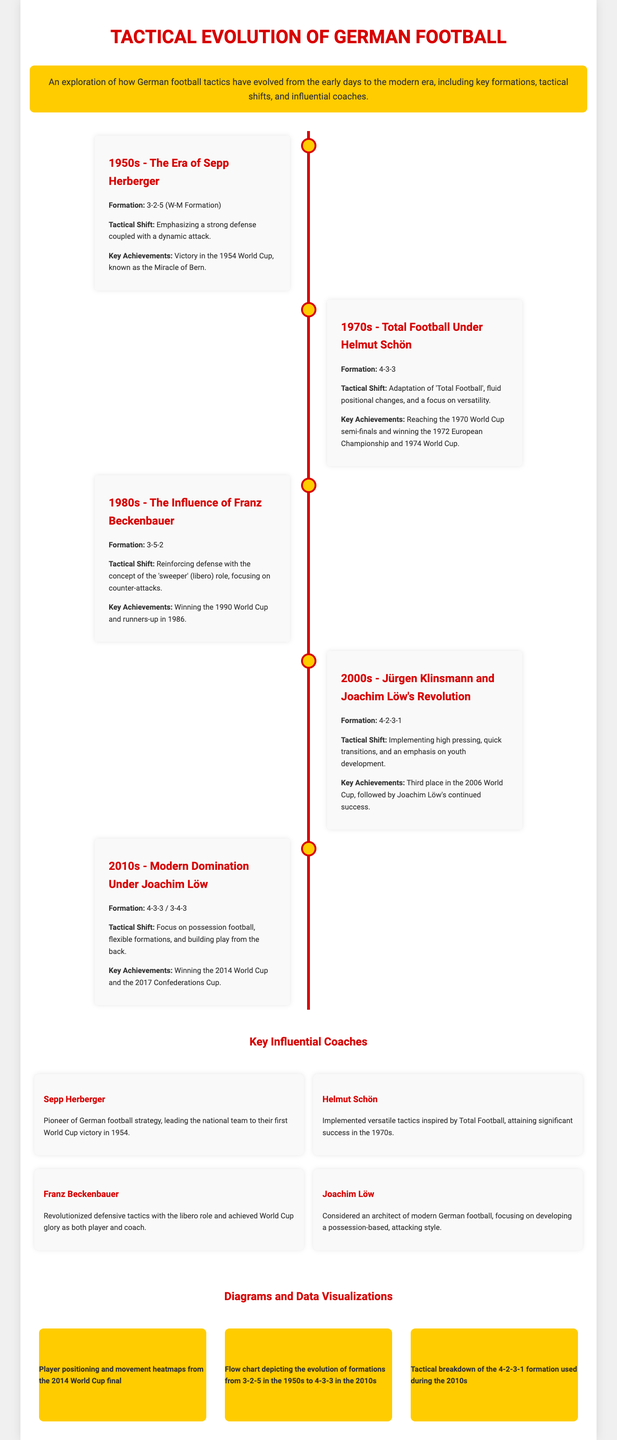What was the formation used in the 1950s? The 1950s era used the 3-2-5 formation, also known as the W-M Formation.
Answer: 3-2-5 Who was the coach during the 1970s? The coach during the 1970s was Helmut Schön.
Answer: Helmut Schön Which World Cup did Germany win in 1990? The document states Germany won the World Cup, specifically mentioning 1990 as a key achievement.
Answer: 1990 What was the key tactical shift under Joachim Löw in the 2000s? The key tactical shift was implementing high pressing, quick transitions, and an emphasis on youth development.
Answer: High pressing What is the visual representation of player positioning in the 2014 World Cup final? The infographic contains a visual labeled "Player positioning and movement heatmaps from the 2014 World Cup final".
Answer: Player positioning and movement heatmaps Which formation was dominant in the 2010s? The dominant formations in the 2010s included 4-3-3 and 3-4-3.
Answer: 4-3-3 / 3-4-3 What was a significant achievement of Sepp Herberger? Sepp Herberger led the national team to their first World Cup victory in 1954, often referred to as a significant achievement.
Answer: 1954 World Cup victory How did the tactical approach change from the 1950s to the 1970s? The document indicates a shift from a more rigid formation to adopting Total Football with fluid positional changes and versatility.
Answer: Total Football What was the focus of training during Joachim Löw's era? The focus during Joachim Löw's era was on developing a possession-based, attacking style of football.
Answer: Possession-based, attacking style 